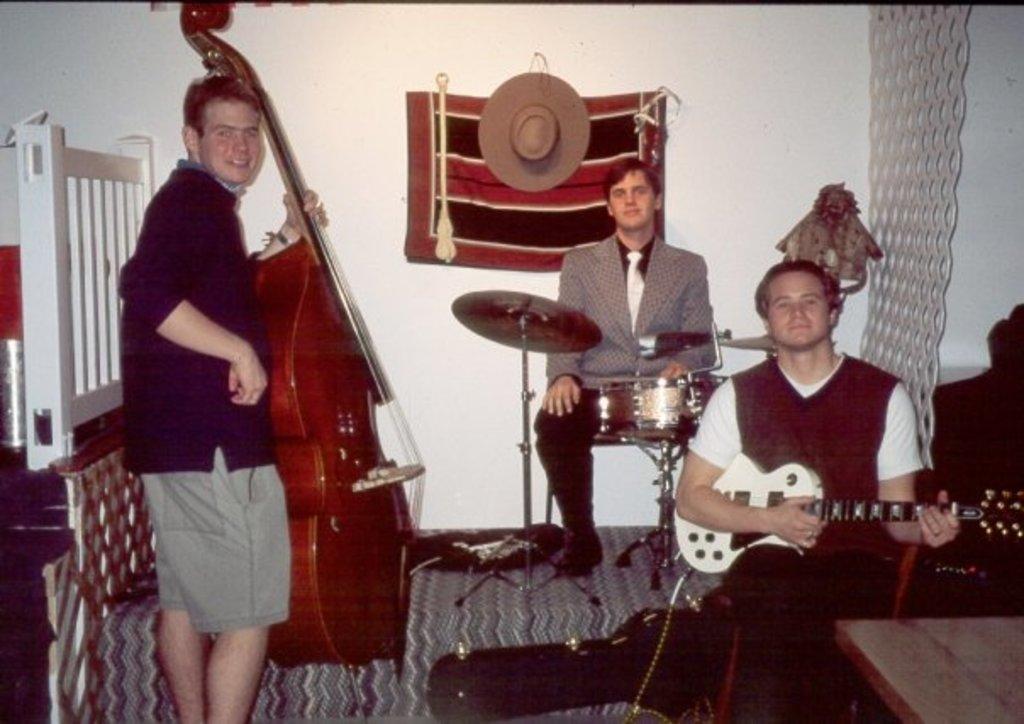Can you describe this image briefly? In this image i can see a person standing and holding a violin in his hand and two other persons are sitting and holding a musical instruments in their hands. In the background i can see a wall and a hat and a railing. 